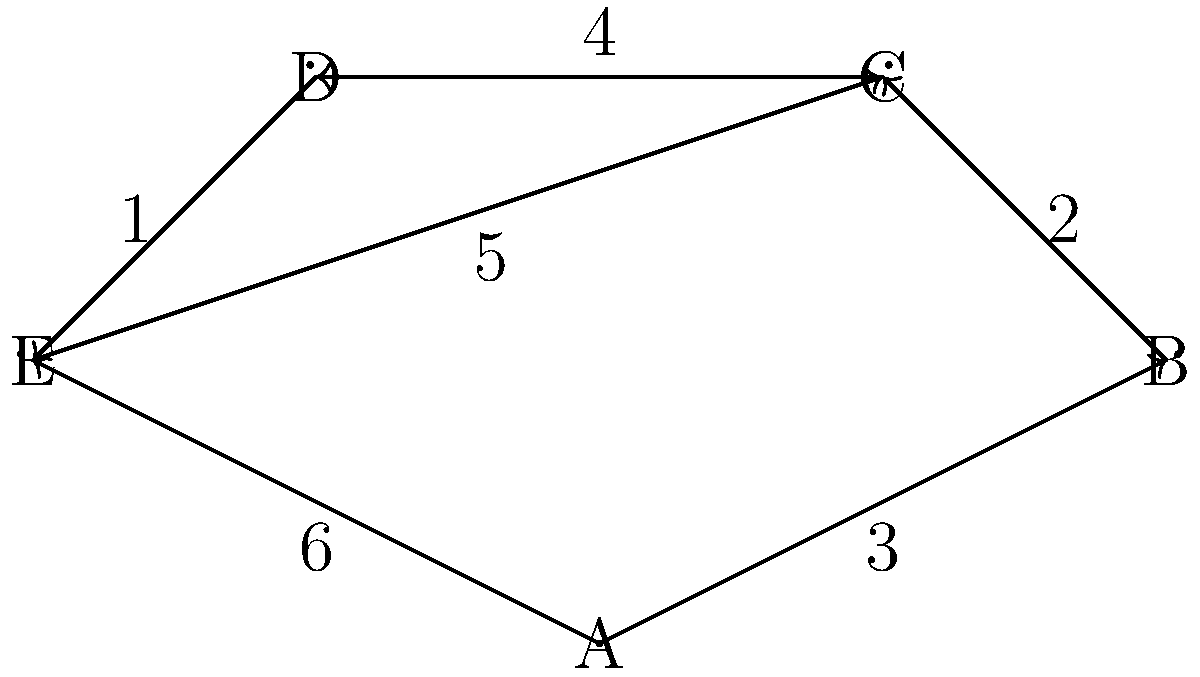In a network of pharmacies, each node represents a pharmacy, and the edges represent delivery routes with associated travel times (in minutes). What is the shortest time required to deliver medications from Pharmacy A to Pharmacy D? To find the shortest path from Pharmacy A to Pharmacy D, we'll use Dijkstra's algorithm:

1. Initialize:
   - Distance to A: 0
   - Distance to all other nodes: infinity
   - Unvisited nodes: A, B, C, D, E

2. From A:
   - Update B: min(∞, 0 + 3) = 3
   - Update E: min(∞, 0 + 6) = 6
   - Mark A as visited

3. Select B (smallest distance):
   - Update C: min(∞, 3 + 2) = 5
   - Mark B as visited

4. Select C:
   - Update D: min(∞, 5 + 4) = 9
   - Mark C as visited

5. Select E:
   - Update C: min(5, 6 + 5) = 5 (no change)
   - Update D: min(9, 6 + 1) = 7
   - Mark E as visited

6. Select D:
   - All nodes visited, algorithm terminates

The shortest path from A to D is A → E → D, with a total time of 7 minutes.
Answer: 7 minutes 